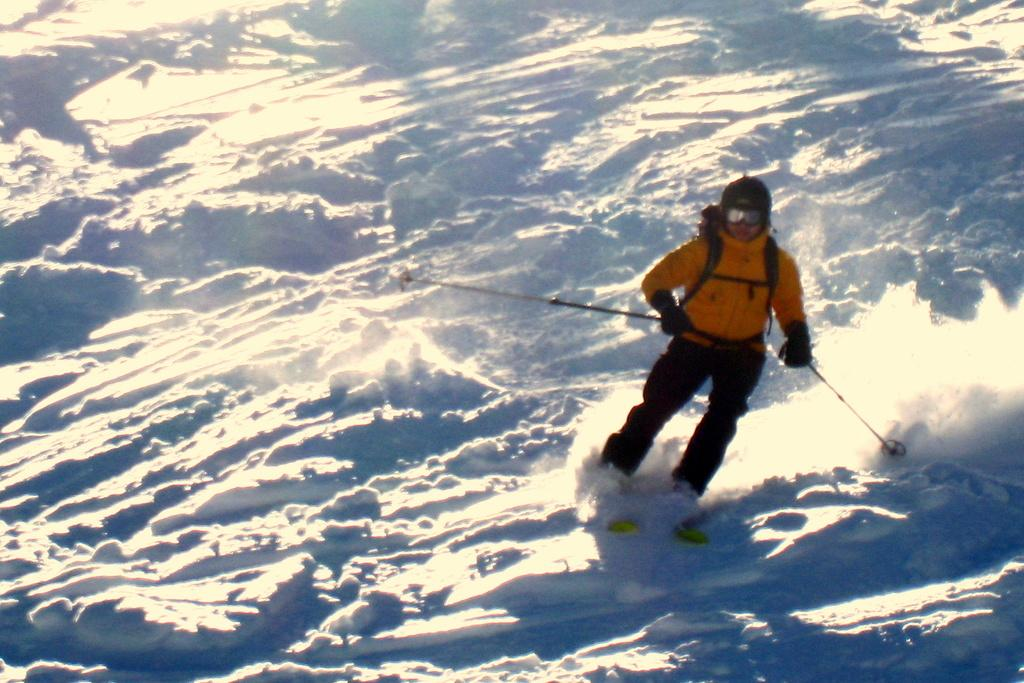Who is the main subject in the image? There is a man in the image. What is the man doing in the image? The man is skiing. What color is the jacket the man is wearing? The man is wearing a yellow jacket. What type of terrain can be seen in the image? There is snow visible at the bottom of the image. What equipment is the man using for skiing? The man is holding ski rods. What type of tax is being discussed in the image? There is no discussion of tax in the image; it features a man skiing in the snow. What town is visible in the background of the image? There is no town visible in the image; it shows a man skiing in a snowy environment. 